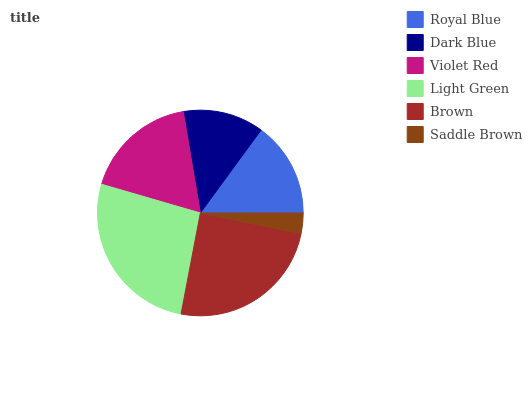Is Saddle Brown the minimum?
Answer yes or no. Yes. Is Light Green the maximum?
Answer yes or no. Yes. Is Dark Blue the minimum?
Answer yes or no. No. Is Dark Blue the maximum?
Answer yes or no. No. Is Royal Blue greater than Dark Blue?
Answer yes or no. Yes. Is Dark Blue less than Royal Blue?
Answer yes or no. Yes. Is Dark Blue greater than Royal Blue?
Answer yes or no. No. Is Royal Blue less than Dark Blue?
Answer yes or no. No. Is Violet Red the high median?
Answer yes or no. Yes. Is Royal Blue the low median?
Answer yes or no. Yes. Is Brown the high median?
Answer yes or no. No. Is Dark Blue the low median?
Answer yes or no. No. 